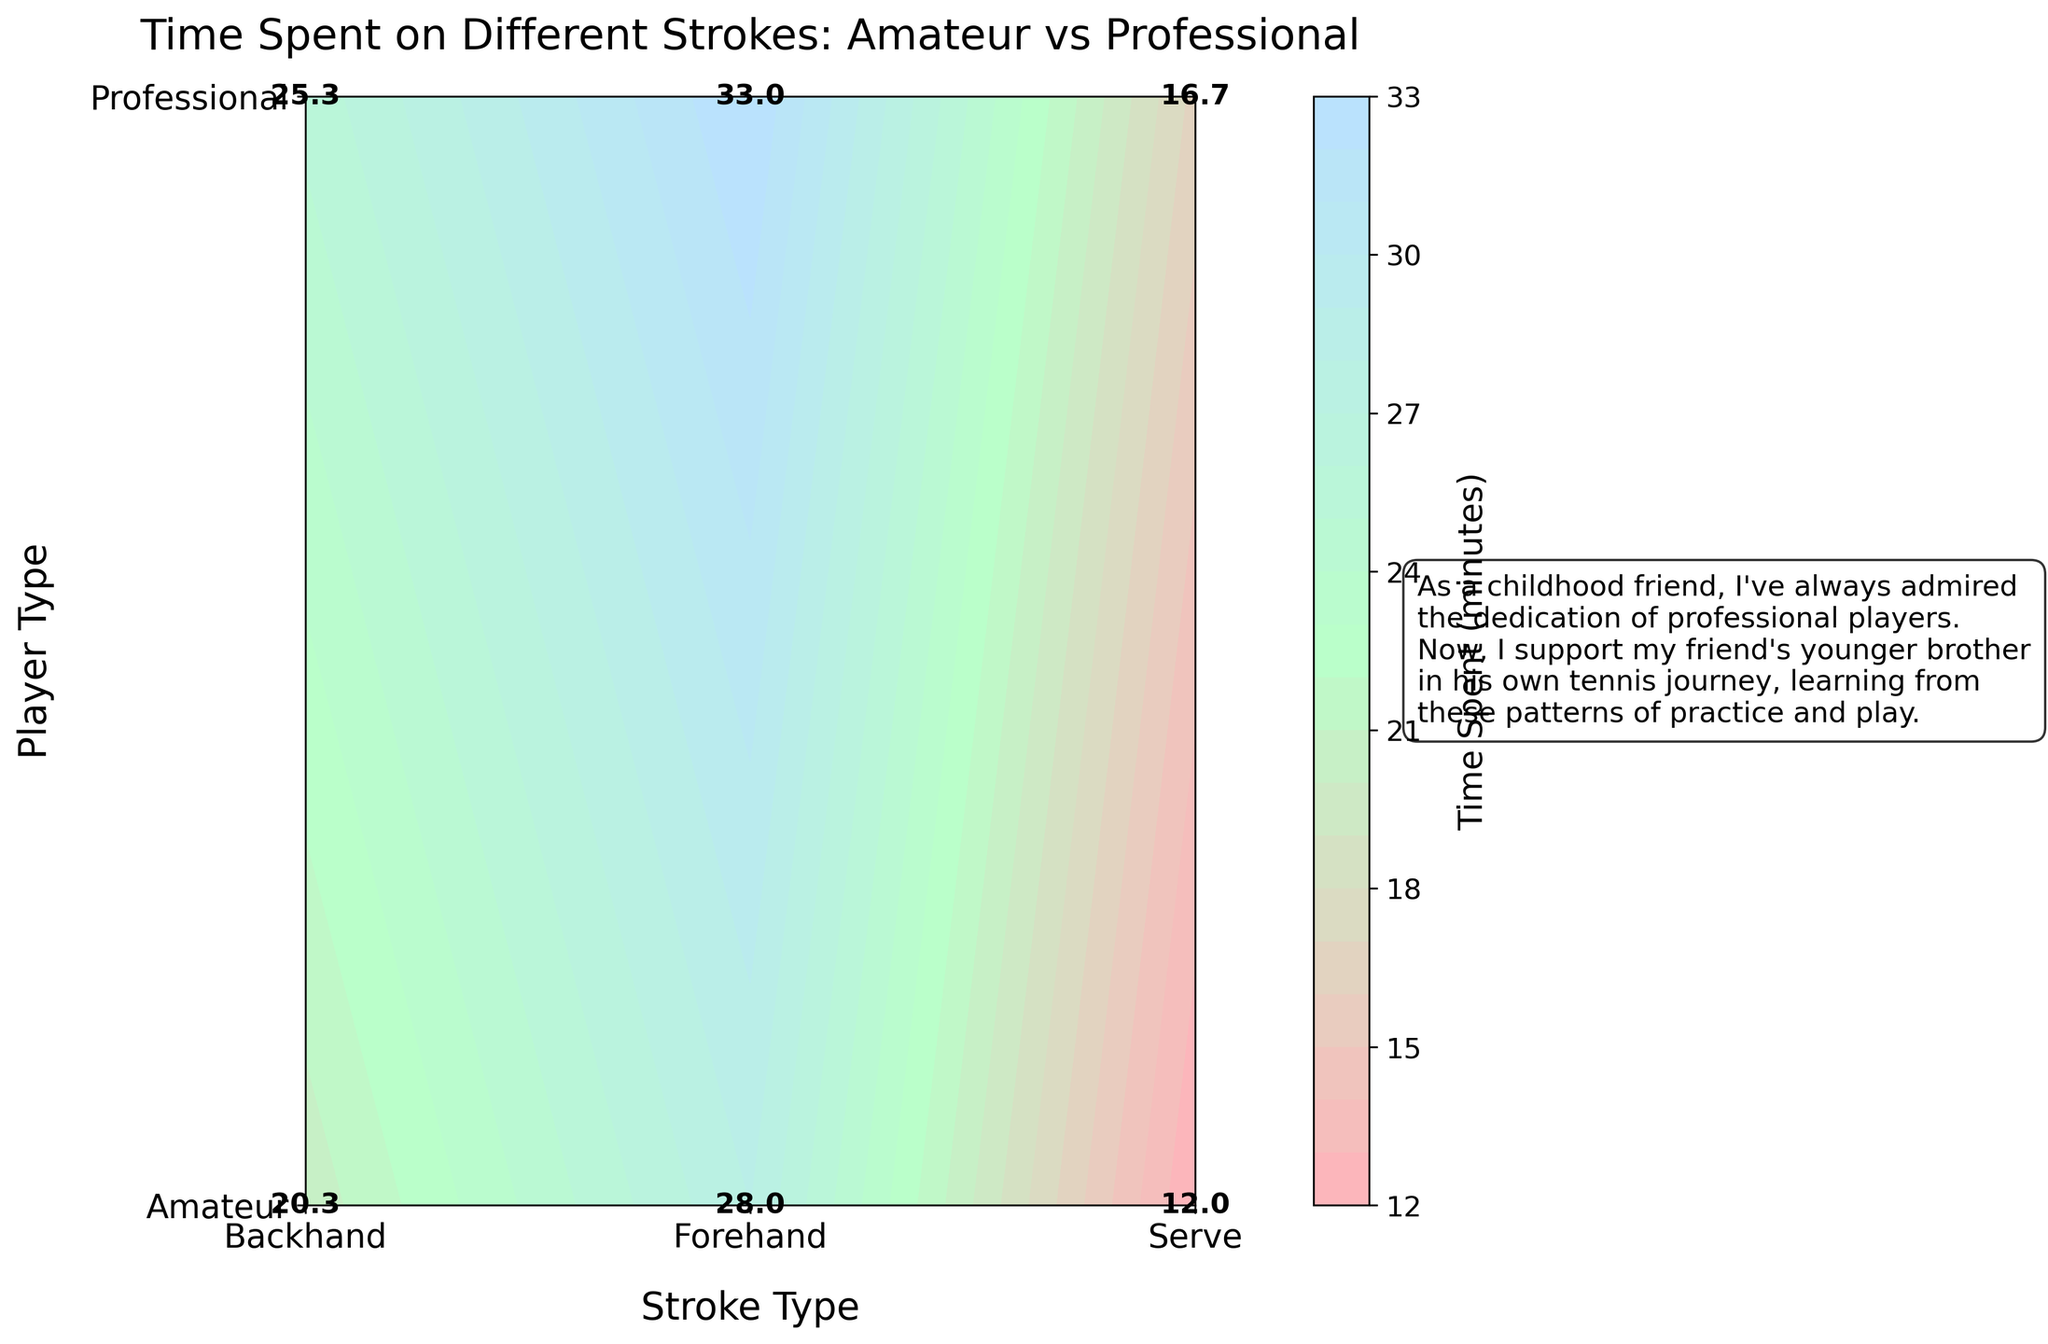what are the x-axis and y-axis labels? The x-axis label represents the types of strokes (Forehand, Backhand, Serve) and the y-axis label represents the types of players (Amateur, Professional). This is based on the text at the bottom and side of the plot.
Answer: Stroke type; Player type What is the average time spent on the backhand by professional players? To find the average time spent on the backhand by professional players, look at the text label for the intersection of Professional (y-axis) and Backhand (x-axis). This value is provided as 25.3 minutes.
Answer: 25.3 minutes Which player type spends more time on serves on average? Compare the labels at the intersection of 'Serve' and both player types. The text labels show "12.5" for amateurs and "16.7" for professionals. Therefore, professionals spend more time on serves on average.
Answer: Professionals What's the total time spent on strokes by amateur players? To find the total time spent by amateur players, sum the values at the intersections for 'Forehand', 'Backhand', and 'Serve' under 'Amateur'. These values are 28.0, 22.0, and 12.0 minutes respectively. The total is 28 + 22 + 12 = 62.
Answer: 62 minutes How does the time spent on forehand by professional players compare to amateurs? Look at the forehand time for both player types: 'Forehand' for professional is 33.0 minutes while for amateur it's 28.0 minutes. Thus, professionals spend more time on forehands.
Answer: Professionals spend more time What's the difference in time spent on backhand strokes between amateur and professional players? The time spent on backhand by amateurs is 22.0 minutes while for professionals it is 25.3 minutes. The difference is 25.3 - 22.0 = 3.3 minutes.
Answer: 3.3 minutes Which stroke type do professional players spend the least time on? Compare the values of time spent (labels in the plot) for professionals across all stroke types. 'Serve' has the lowest value of 16.7 minutes.
Answer: Serve If we combine the average time spent on forehand and backhand by amateur players, what is the total? Sum the average time spent on forehand (28.0 minutes) and backhand (22.0 minutes) by amateurs: 28 + 22 = 50 minutes.
Answer: 50 minutes 